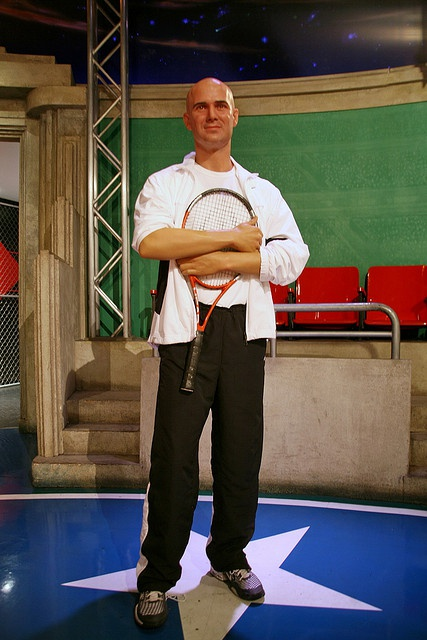Describe the objects in this image and their specific colors. I can see people in black, lightgray, brown, and tan tones, tennis racket in black, lightgray, maroon, and gray tones, chair in black, maroon, and gray tones, chair in black, maroon, and lightgray tones, and chair in black, darkgreen, and maroon tones in this image. 